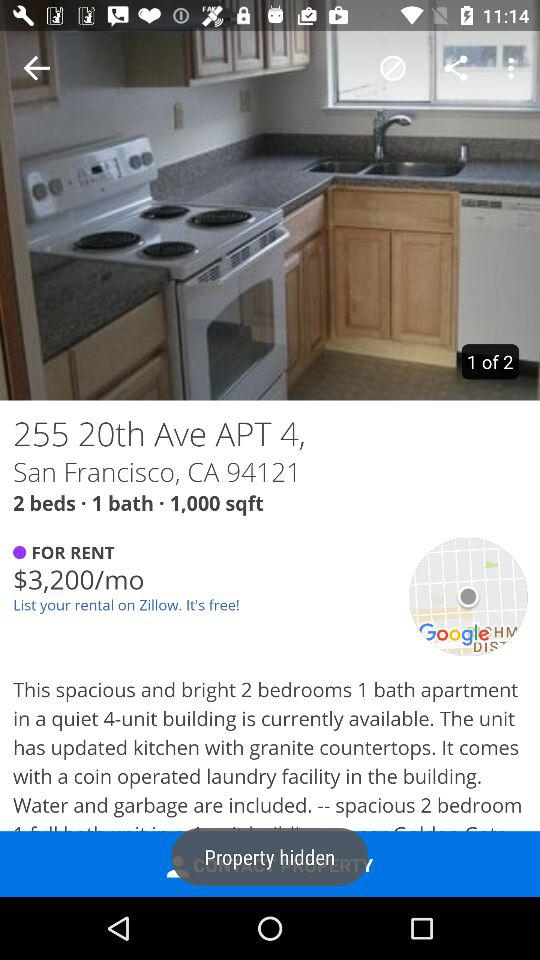How many beds does the apartment have?
Answer the question using a single word or phrase. 2 